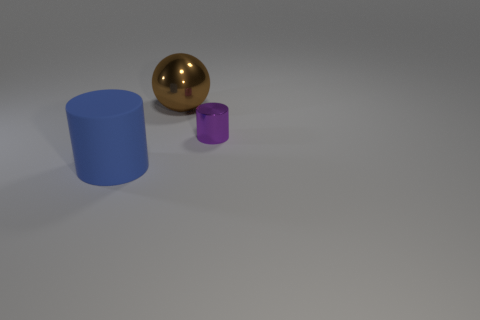Is there any visible texture on the objects or the surface they are on? The objects and the surface appear to be quite smooth, with the exception of some subtle graininess on the surface which might suggest a slight texture. This kind of texture is usually associated with matte finishes rather than glossy ones. 